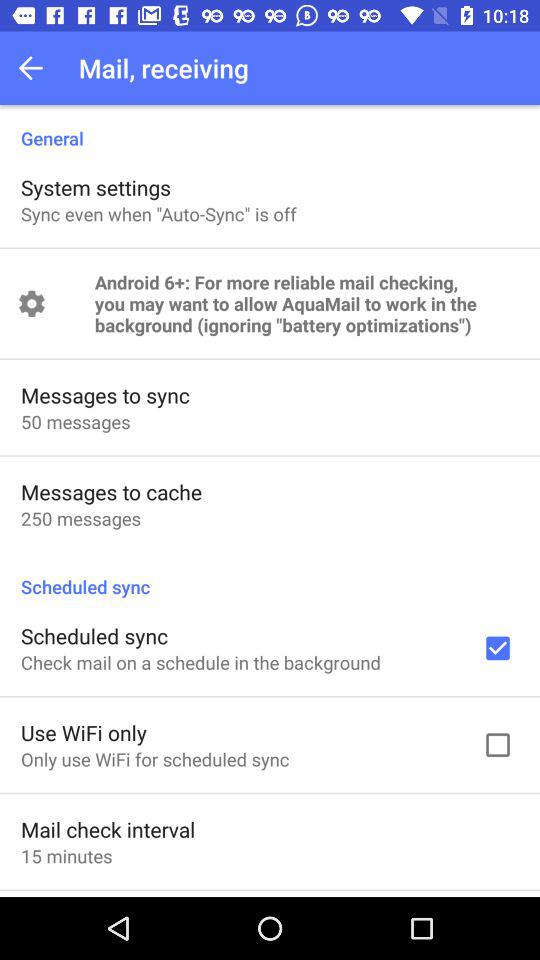How many messages are there to cache? There are 250 messages to cache. 